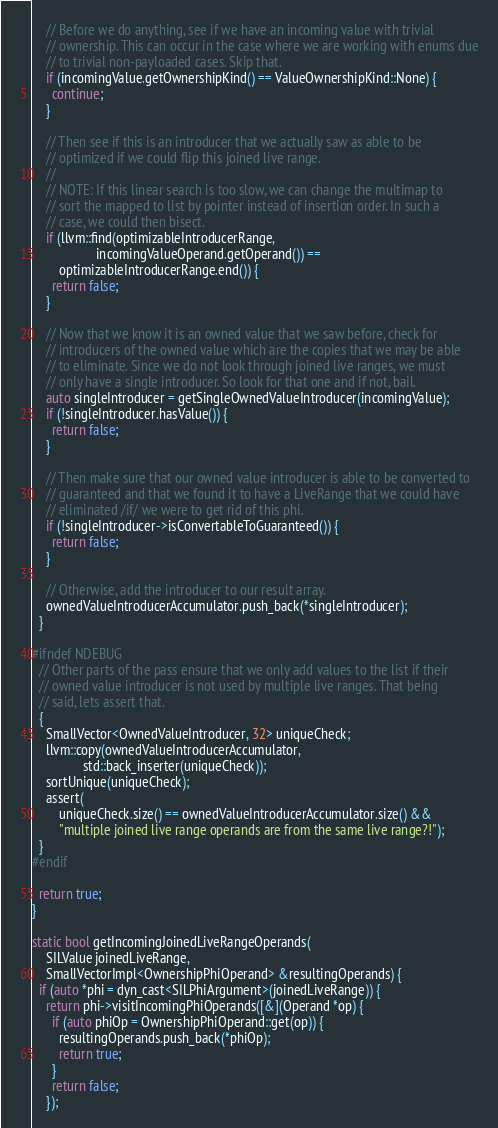Convert code to text. <code><loc_0><loc_0><loc_500><loc_500><_C++_>
    // Before we do anything, see if we have an incoming value with trivial
    // ownership. This can occur in the case where we are working with enums due
    // to trivial non-payloaded cases. Skip that.
    if (incomingValue.getOwnershipKind() == ValueOwnershipKind::None) {
      continue;
    }

    // Then see if this is an introducer that we actually saw as able to be
    // optimized if we could flip this joined live range.
    //
    // NOTE: If this linear search is too slow, we can change the multimap to
    // sort the mapped to list by pointer instead of insertion order. In such a
    // case, we could then bisect.
    if (llvm::find(optimizableIntroducerRange,
                   incomingValueOperand.getOperand()) ==
        optimizableIntroducerRange.end()) {
      return false;
    }

    // Now that we know it is an owned value that we saw before, check for
    // introducers of the owned value which are the copies that we may be able
    // to eliminate. Since we do not look through joined live ranges, we must
    // only have a single introducer. So look for that one and if not, bail.
    auto singleIntroducer = getSingleOwnedValueIntroducer(incomingValue);
    if (!singleIntroducer.hasValue()) {
      return false;
    }

    // Then make sure that our owned value introducer is able to be converted to
    // guaranteed and that we found it to have a LiveRange that we could have
    // eliminated /if/ we were to get rid of this phi.
    if (!singleIntroducer->isConvertableToGuaranteed()) {
      return false;
    }

    // Otherwise, add the introducer to our result array.
    ownedValueIntroducerAccumulator.push_back(*singleIntroducer);
  }

#ifndef NDEBUG
  // Other parts of the pass ensure that we only add values to the list if their
  // owned value introducer is not used by multiple live ranges. That being
  // said, lets assert that.
  {
    SmallVector<OwnedValueIntroducer, 32> uniqueCheck;
    llvm::copy(ownedValueIntroducerAccumulator,
               std::back_inserter(uniqueCheck));
    sortUnique(uniqueCheck);
    assert(
        uniqueCheck.size() == ownedValueIntroducerAccumulator.size() &&
        "multiple joined live range operands are from the same live range?!");
  }
#endif

  return true;
}

static bool getIncomingJoinedLiveRangeOperands(
    SILValue joinedLiveRange,
    SmallVectorImpl<OwnershipPhiOperand> &resultingOperands) {
  if (auto *phi = dyn_cast<SILPhiArgument>(joinedLiveRange)) {
    return phi->visitIncomingPhiOperands([&](Operand *op) {
      if (auto phiOp = OwnershipPhiOperand::get(op)) {
        resultingOperands.push_back(*phiOp);
        return true;
      }
      return false;
    });</code> 